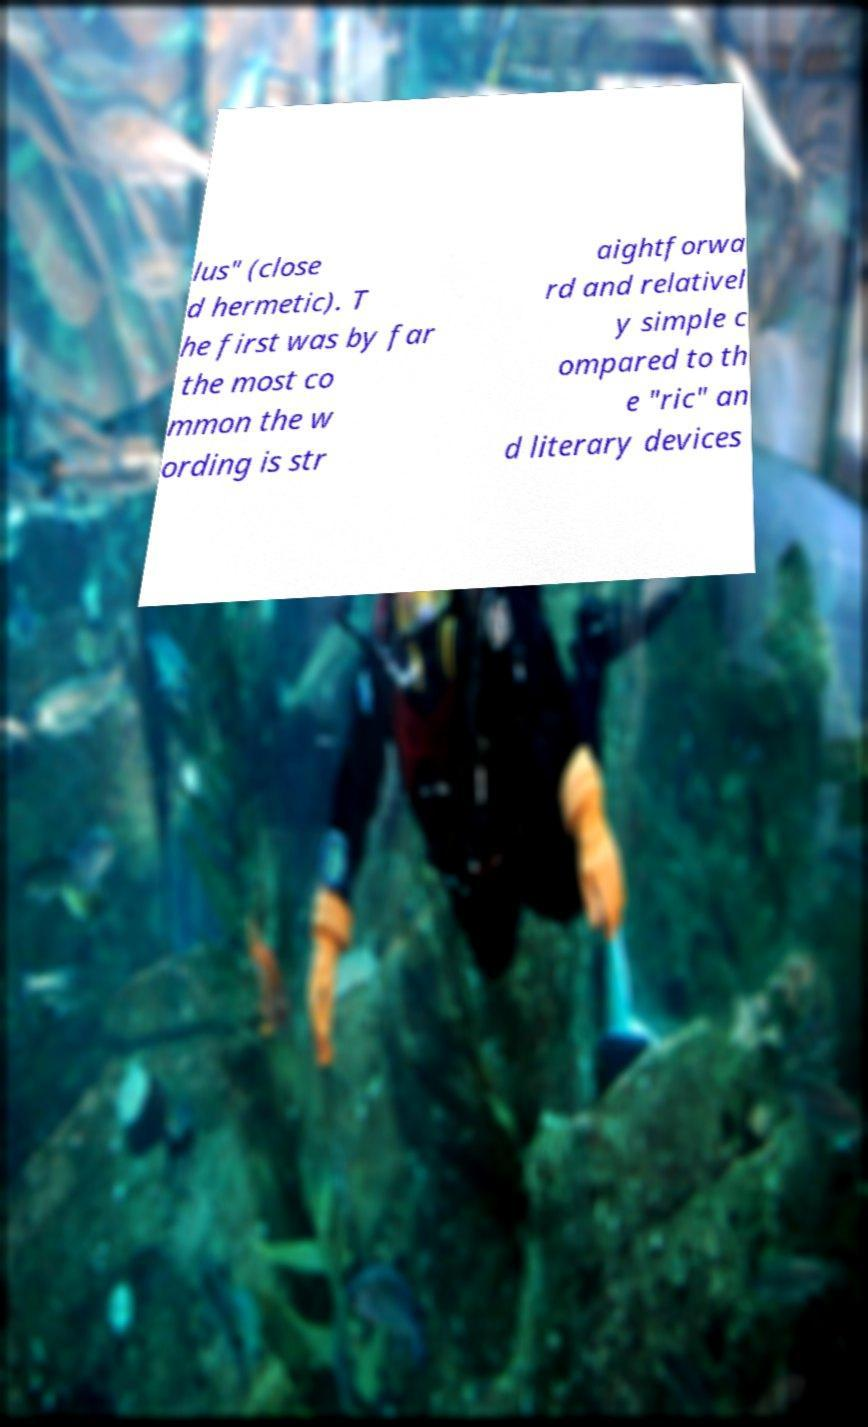I need the written content from this picture converted into text. Can you do that? lus" (close d hermetic). T he first was by far the most co mmon the w ording is str aightforwa rd and relativel y simple c ompared to th e "ric" an d literary devices 